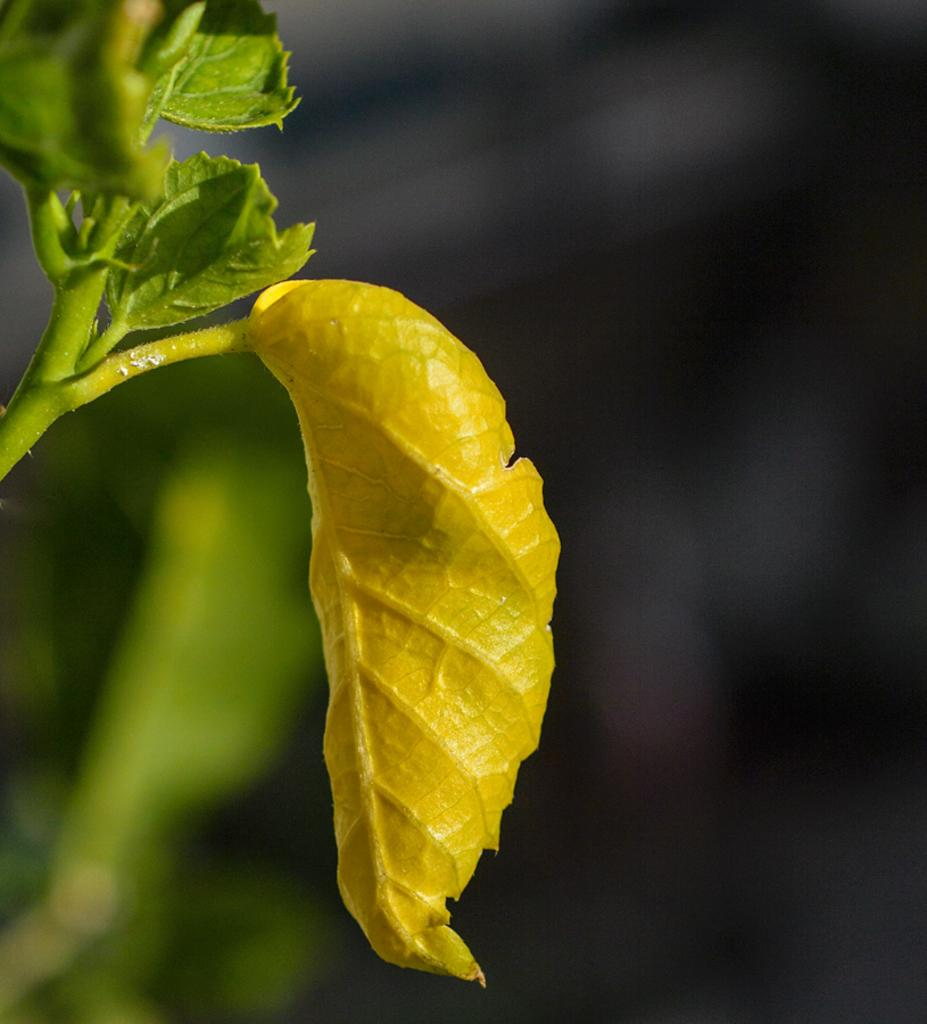What is present in the image? There is a plant in the image. Can you describe the plant's leaves? The plant has multiple leaves. What colors can be seen on the leaves? The leaves have both yellow and green colors. What type of voyage is the plant taking in the image? There is no voyage present in the image; it is a stationary plant. What time of day is it in the image? The time of day cannot be determined from the image. 